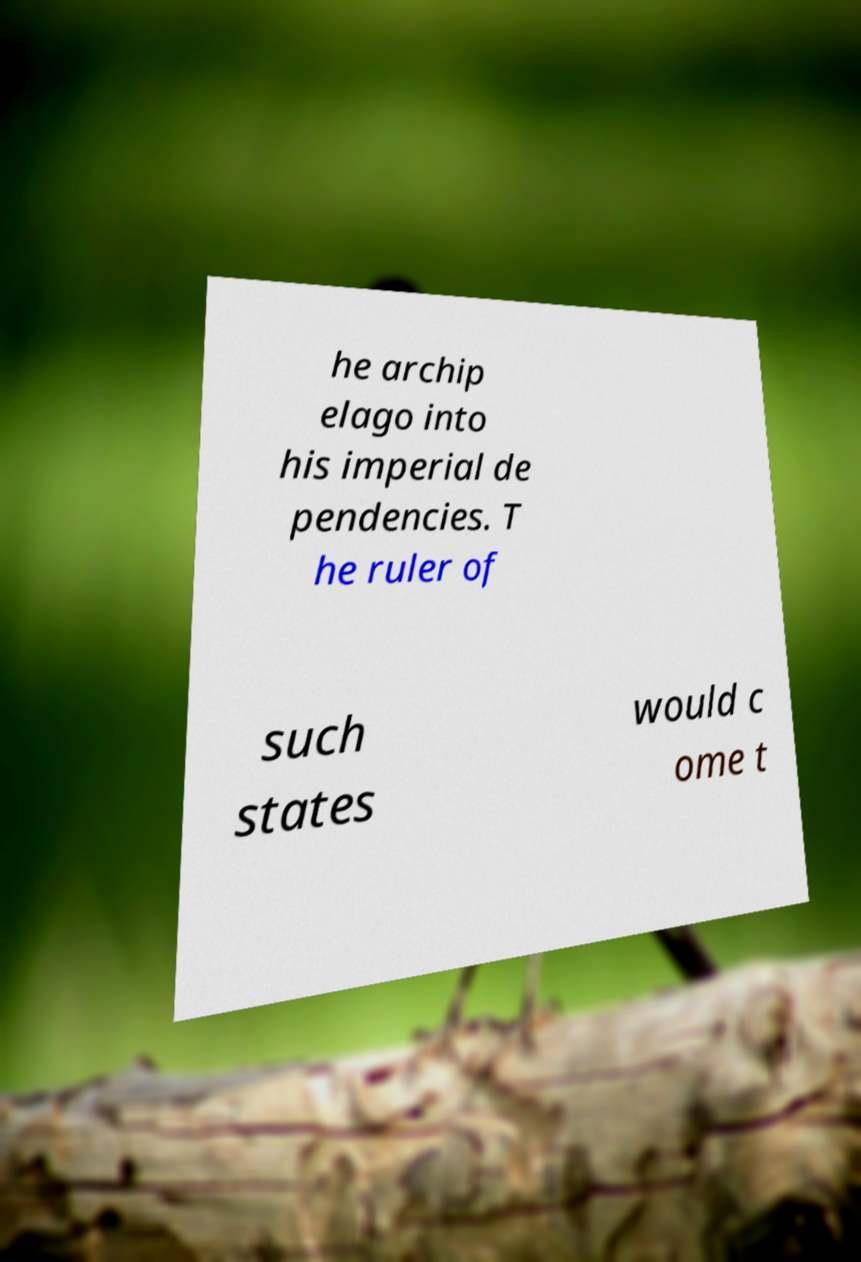There's text embedded in this image that I need extracted. Can you transcribe it verbatim? he archip elago into his imperial de pendencies. T he ruler of such states would c ome t 